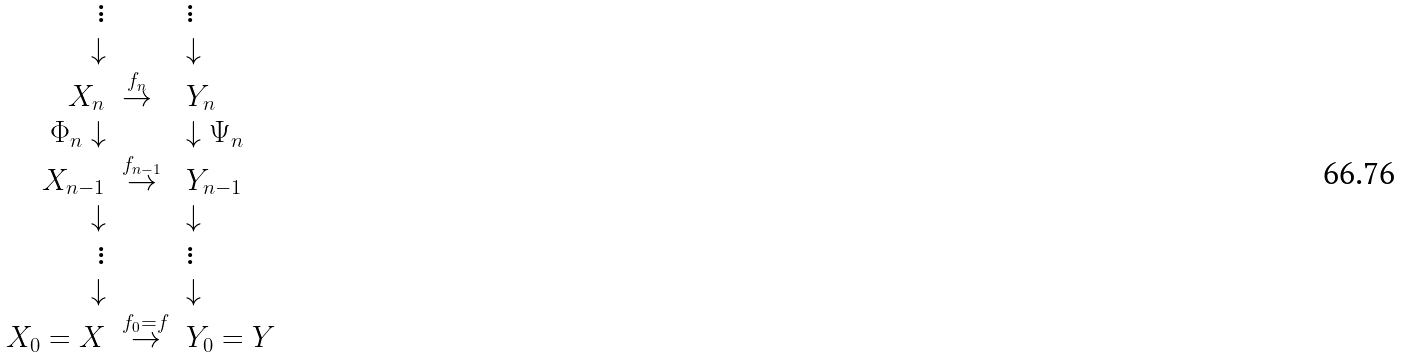<formula> <loc_0><loc_0><loc_500><loc_500>\begin{array} { r l l } \vdots & & \vdots \\ \downarrow & & \downarrow \\ X _ { n } & \stackrel { f _ { n } } { \rightarrow } & Y _ { n } \\ \Phi _ { n } \downarrow & & \downarrow \Psi _ { n } \\ X _ { n - 1 } & \stackrel { f _ { n - 1 } } { \rightarrow } & Y _ { n - 1 } \\ \downarrow & & \downarrow \\ \vdots & & \vdots \\ \downarrow & & \downarrow \\ X _ { 0 } = X & \stackrel { f _ { 0 } = f } { \rightarrow } & Y _ { 0 } = Y \end{array}</formula> 